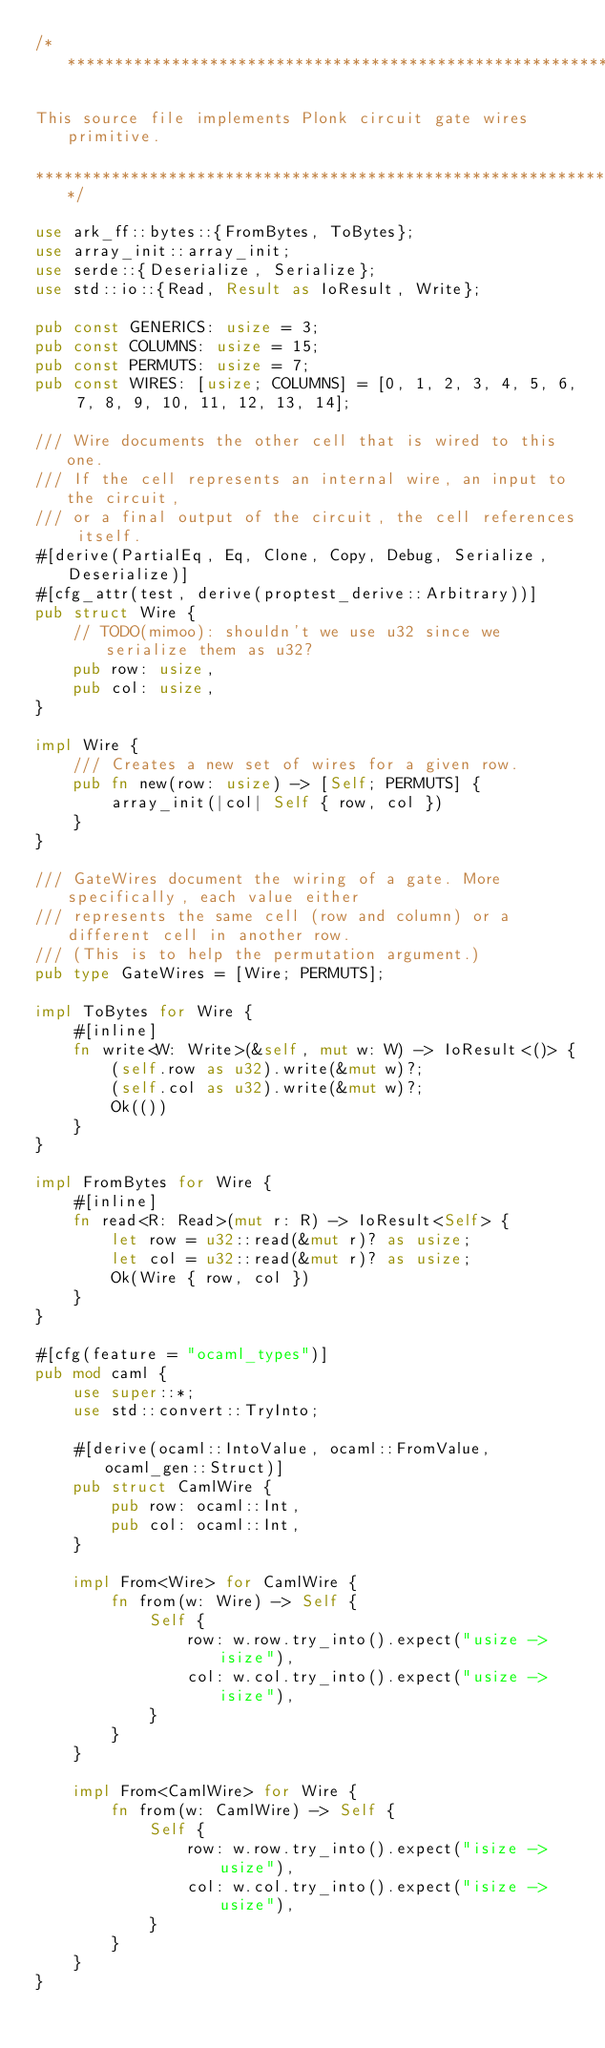<code> <loc_0><loc_0><loc_500><loc_500><_Rust_>/*****************************************************************************************************************

This source file implements Plonk circuit gate wires primitive.

*****************************************************************************************************************/

use ark_ff::bytes::{FromBytes, ToBytes};
use array_init::array_init;
use serde::{Deserialize, Serialize};
use std::io::{Read, Result as IoResult, Write};

pub const GENERICS: usize = 3;
pub const COLUMNS: usize = 15;
pub const PERMUTS: usize = 7;
pub const WIRES: [usize; COLUMNS] = [0, 1, 2, 3, 4, 5, 6, 7, 8, 9, 10, 11, 12, 13, 14];

/// Wire documents the other cell that is wired to this one.
/// If the cell represents an internal wire, an input to the circuit,
/// or a final output of the circuit, the cell references itself.
#[derive(PartialEq, Eq, Clone, Copy, Debug, Serialize, Deserialize)]
#[cfg_attr(test, derive(proptest_derive::Arbitrary))]
pub struct Wire {
    // TODO(mimoo): shouldn't we use u32 since we serialize them as u32?
    pub row: usize,
    pub col: usize,
}

impl Wire {
    /// Creates a new set of wires for a given row.
    pub fn new(row: usize) -> [Self; PERMUTS] {
        array_init(|col| Self { row, col })
    }
}

/// GateWires document the wiring of a gate. More specifically, each value either
/// represents the same cell (row and column) or a different cell in another row.
/// (This is to help the permutation argument.)
pub type GateWires = [Wire; PERMUTS];

impl ToBytes for Wire {
    #[inline]
    fn write<W: Write>(&self, mut w: W) -> IoResult<()> {
        (self.row as u32).write(&mut w)?;
        (self.col as u32).write(&mut w)?;
        Ok(())
    }
}

impl FromBytes for Wire {
    #[inline]
    fn read<R: Read>(mut r: R) -> IoResult<Self> {
        let row = u32::read(&mut r)? as usize;
        let col = u32::read(&mut r)? as usize;
        Ok(Wire { row, col })
    }
}

#[cfg(feature = "ocaml_types")]
pub mod caml {
    use super::*;
    use std::convert::TryInto;

    #[derive(ocaml::IntoValue, ocaml::FromValue, ocaml_gen::Struct)]
    pub struct CamlWire {
        pub row: ocaml::Int,
        pub col: ocaml::Int,
    }

    impl From<Wire> for CamlWire {
        fn from(w: Wire) -> Self {
            Self {
                row: w.row.try_into().expect("usize -> isize"),
                col: w.col.try_into().expect("usize -> isize"),
            }
        }
    }

    impl From<CamlWire> for Wire {
        fn from(w: CamlWire) -> Self {
            Self {
                row: w.row.try_into().expect("isize -> usize"),
                col: w.col.try_into().expect("isize -> usize"),
            }
        }
    }
}
</code> 